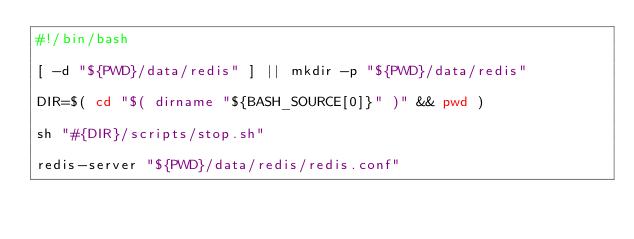<code> <loc_0><loc_0><loc_500><loc_500><_Bash_>#!/bin/bash

[ -d "${PWD}/data/redis" ] || mkdir -p "${PWD}/data/redis"

DIR=$( cd "$( dirname "${BASH_SOURCE[0]}" )" && pwd )

sh "#{DIR}/scripts/stop.sh"

redis-server "${PWD}/data/redis/redis.conf"
</code> 